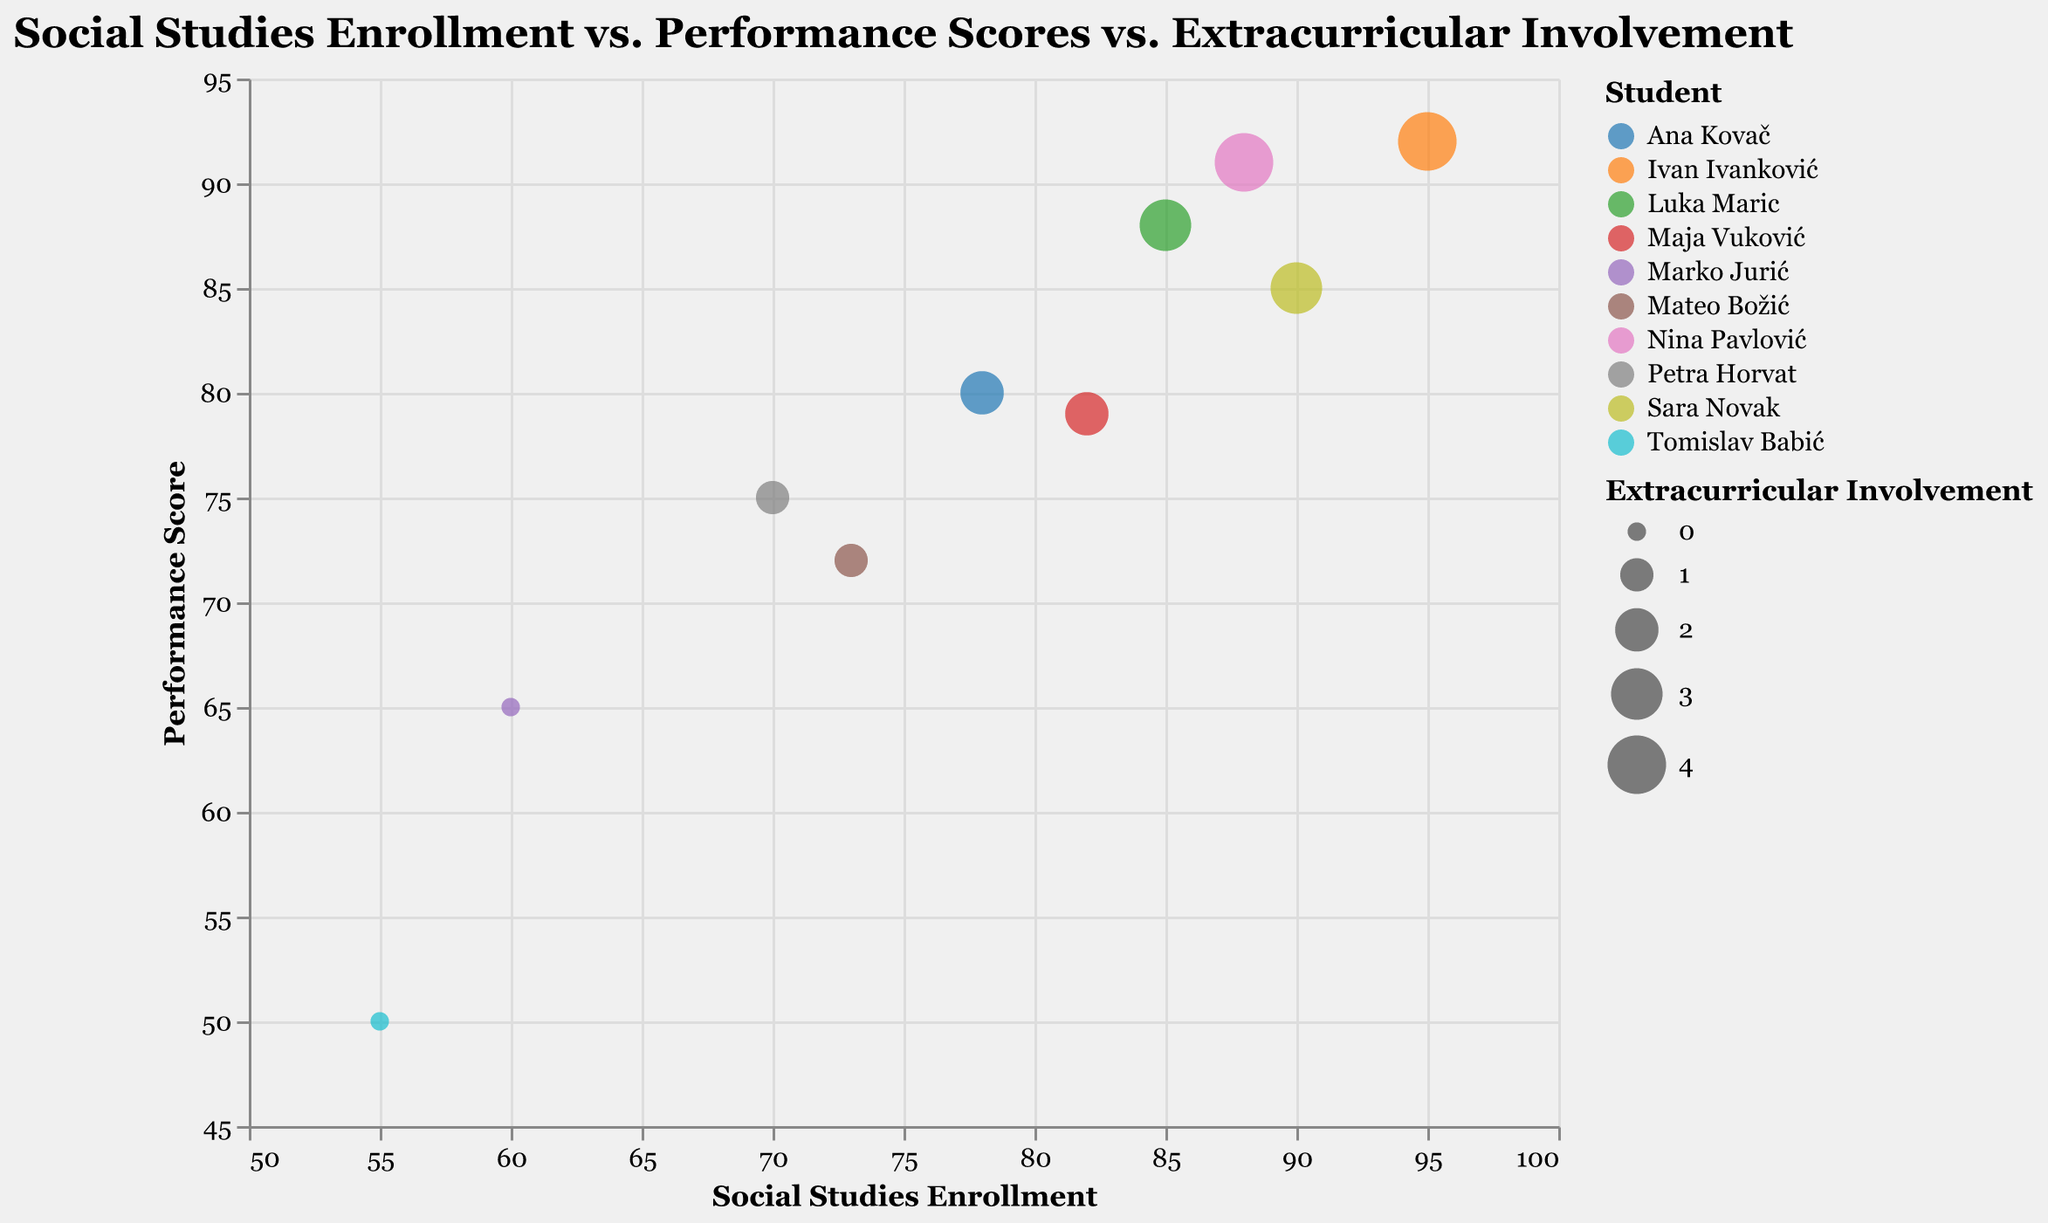What is the title of the bubble chart? The title of the bubble chart is prominently displayed at the top and often provides a summary of the chart's focus. In this case, it is clearly given.
Answer: Social Studies Enrollment vs. Performance Scores vs. Extracurricular Involvement How many students are represented in the bubble chart? To find the number of students, count the distinct points (or bubbles) on the chart. Each bubble represents one student.
Answer: 10 Which student has the highest social studies enrollment? The student with the highest social studies enrollment is indicated by the bubble positioned furthest along the x-axis, closest to the value of 100.
Answer: Ivan Ivanković What is the range of extracurricular involvement among the students? The range of extracurricular involvement is found by identifying the smallest and largest sizes of the bubbles, which indicate the least and most extracurricular involvement levels.
Answer: 0 to 4 Whose bubble is the largest on the chart? The size of the bubble represents the level of extracurricular involvement. The largest bubble would therefore represent the student with the highest level of extracurricular involvement.
Answer: Ivan Ivanković and Nina Pavlović Who scored the lowest in performance, and what is their extracurricular involvement? Identify the bubble positioned lowest on the y-axis for performance score, and check its size to determine extracurricular involvement.
Answer: Tomislav Babić, 0 What is the average performance score of students with an extracurricular involvement of 3? Identify the performance scores of bubbles with a size indicating an extracurricular involvement of 3, then calculate their average. For Luka Maric (88) and Sara Novak (85): (88 + 85) / 2.
Answer: 86.5 Which two students have nearly the same combination of social studies enrollment and performance score but differ significantly in extracurricular involvement? Look for two bubbles close together in both x and y positions but differing in size.
Answer: Luka Maric and Sara Novak Do students with higher extracurricular involvement tend to have higher performance scores? By observing the chart, check if larger bubbles (indicating higher extracurricular involvement) are generally positioned higher on the y-axis (indicating higher performance scores).
Answer: Generally, yes What correlations can be observed between social studies enrollment and performance scores? By examining the scatter of bubbles horizontally (social studies enrollment) and vertically (performance scores), identify whether a trend or pattern emerges, such as high enrollment correlating with high performance.
Answer: Positive correlation 